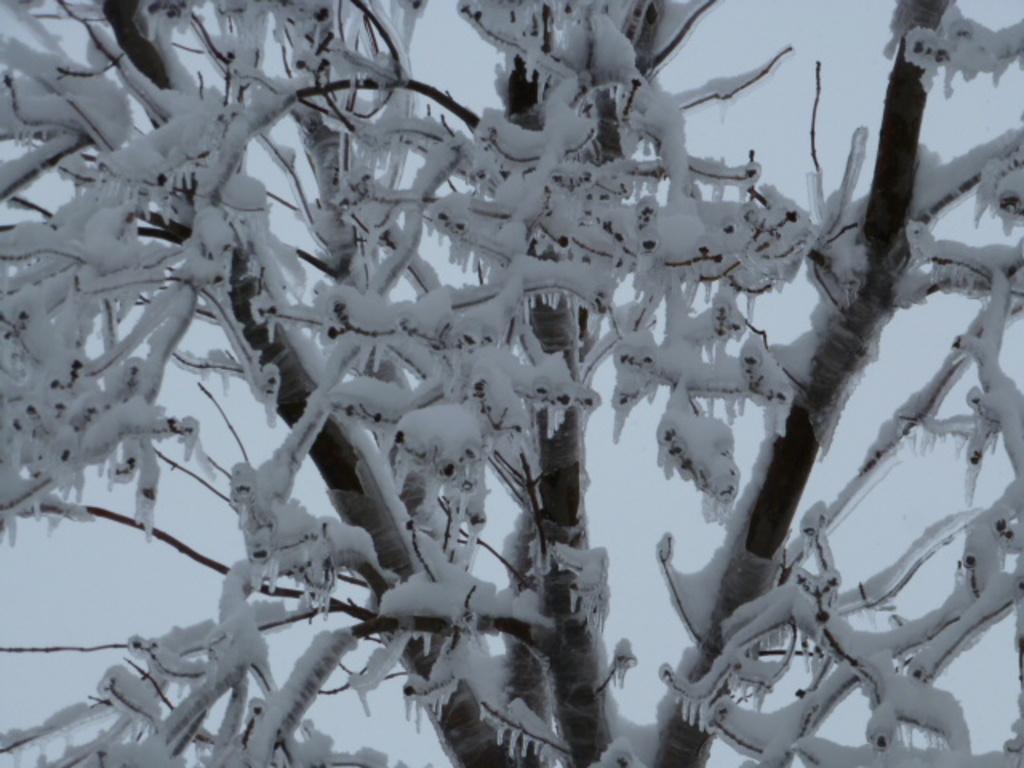Describe this image in one or two sentences. In this picture we can see branches covered with snow. In the background of the image it is white. 